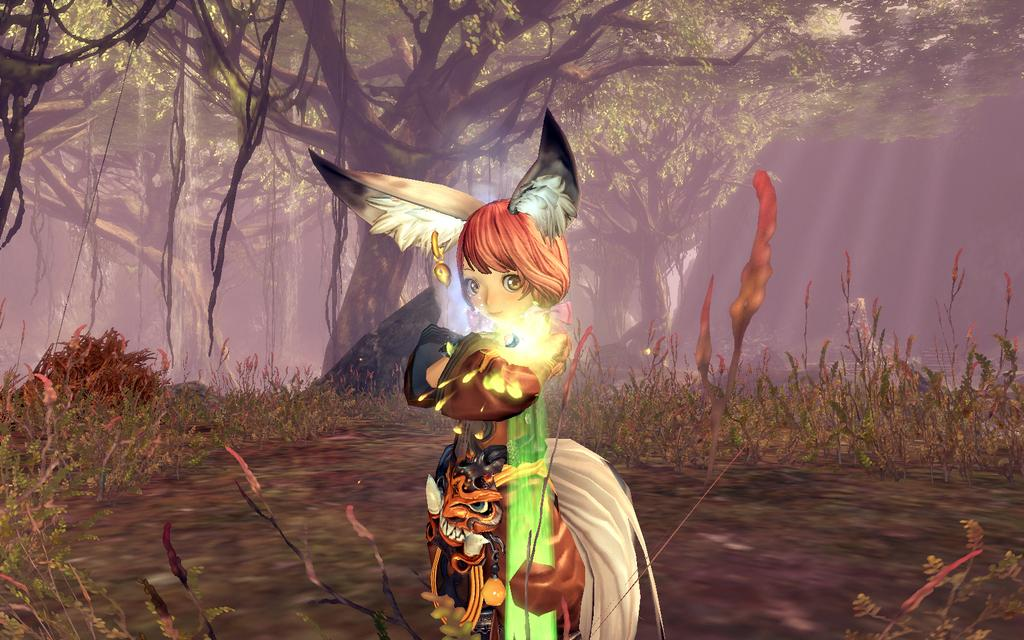What type of image is being described? The image is an animation. Who or what is the main subject in the image? There is a lady in the center of the image. What type of terrain is visible at the bottom of the image? There is grass at the bottom of the image. What can be seen in the background of the image? There are trees in the background of the image. Can you see any damage caused by an earthquake in the image? There is no mention of an earthquake or any damage in the image. The image features a lady, grass, and trees, with no indication of any natural disaster. 